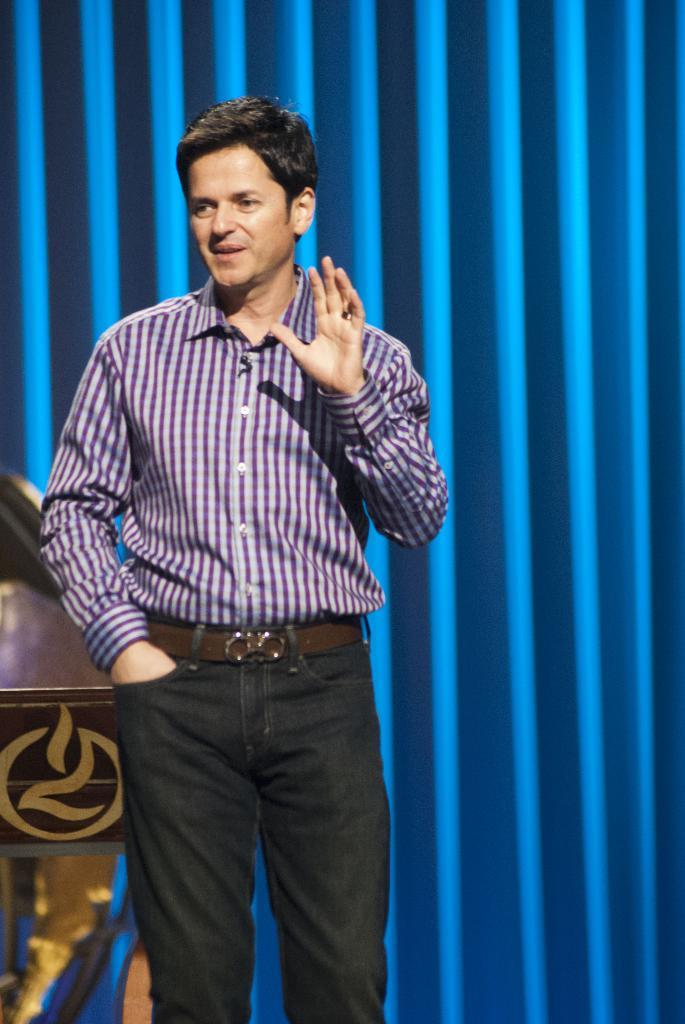What is the main subject of the image? There is a person standing in the center of the image. Can you describe the background of the image? There is a blue color curtain in the background of the image. How many gold vases are present on the table in the image? There is no table or gold vases present in the image; it only features a person standing in the center and a blue color curtain in the background. What type of pigs can be seen in the image? There are no pigs present in the image. 